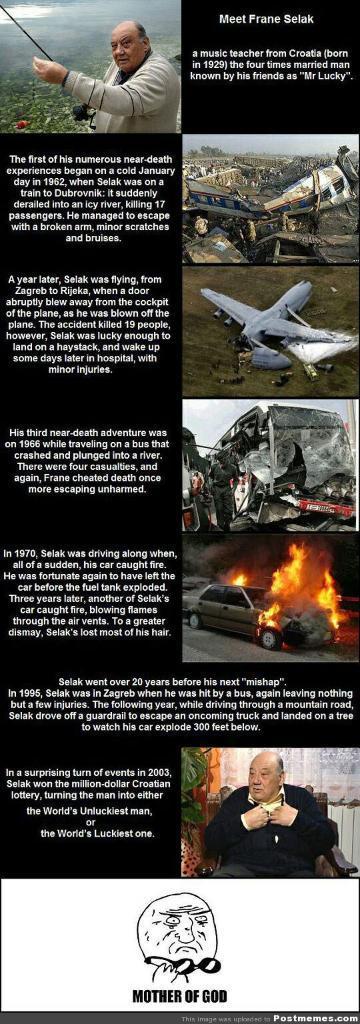Describe this image in one or two sentences. This is a poster and in this poster we can see two people, airplane, car with fire, some objects and some text. 